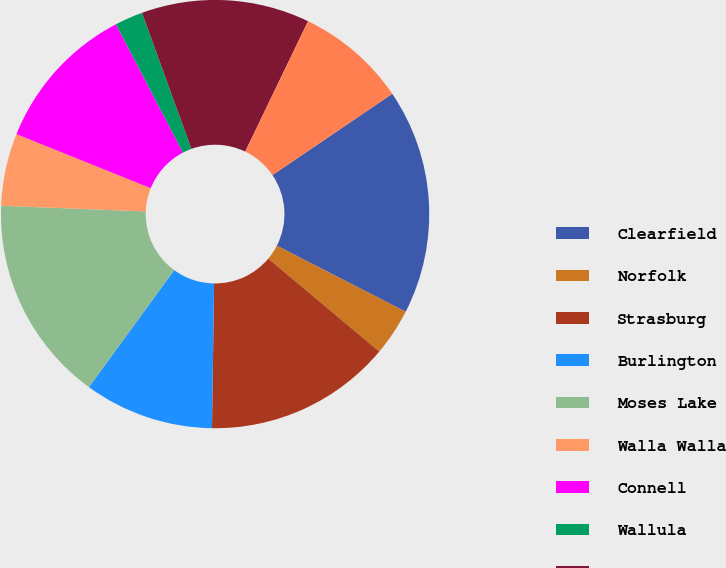Convert chart to OTSL. <chart><loc_0><loc_0><loc_500><loc_500><pie_chart><fcel>Clearfield<fcel>Norfolk<fcel>Strasburg<fcel>Burlington<fcel>Moses Lake<fcel>Walla Walla<fcel>Connell<fcel>Wallula<fcel>Pasco<fcel>Tomah<nl><fcel>17.03%<fcel>3.56%<fcel>14.14%<fcel>9.8%<fcel>15.59%<fcel>5.47%<fcel>11.25%<fcel>2.12%<fcel>12.69%<fcel>8.36%<nl></chart> 